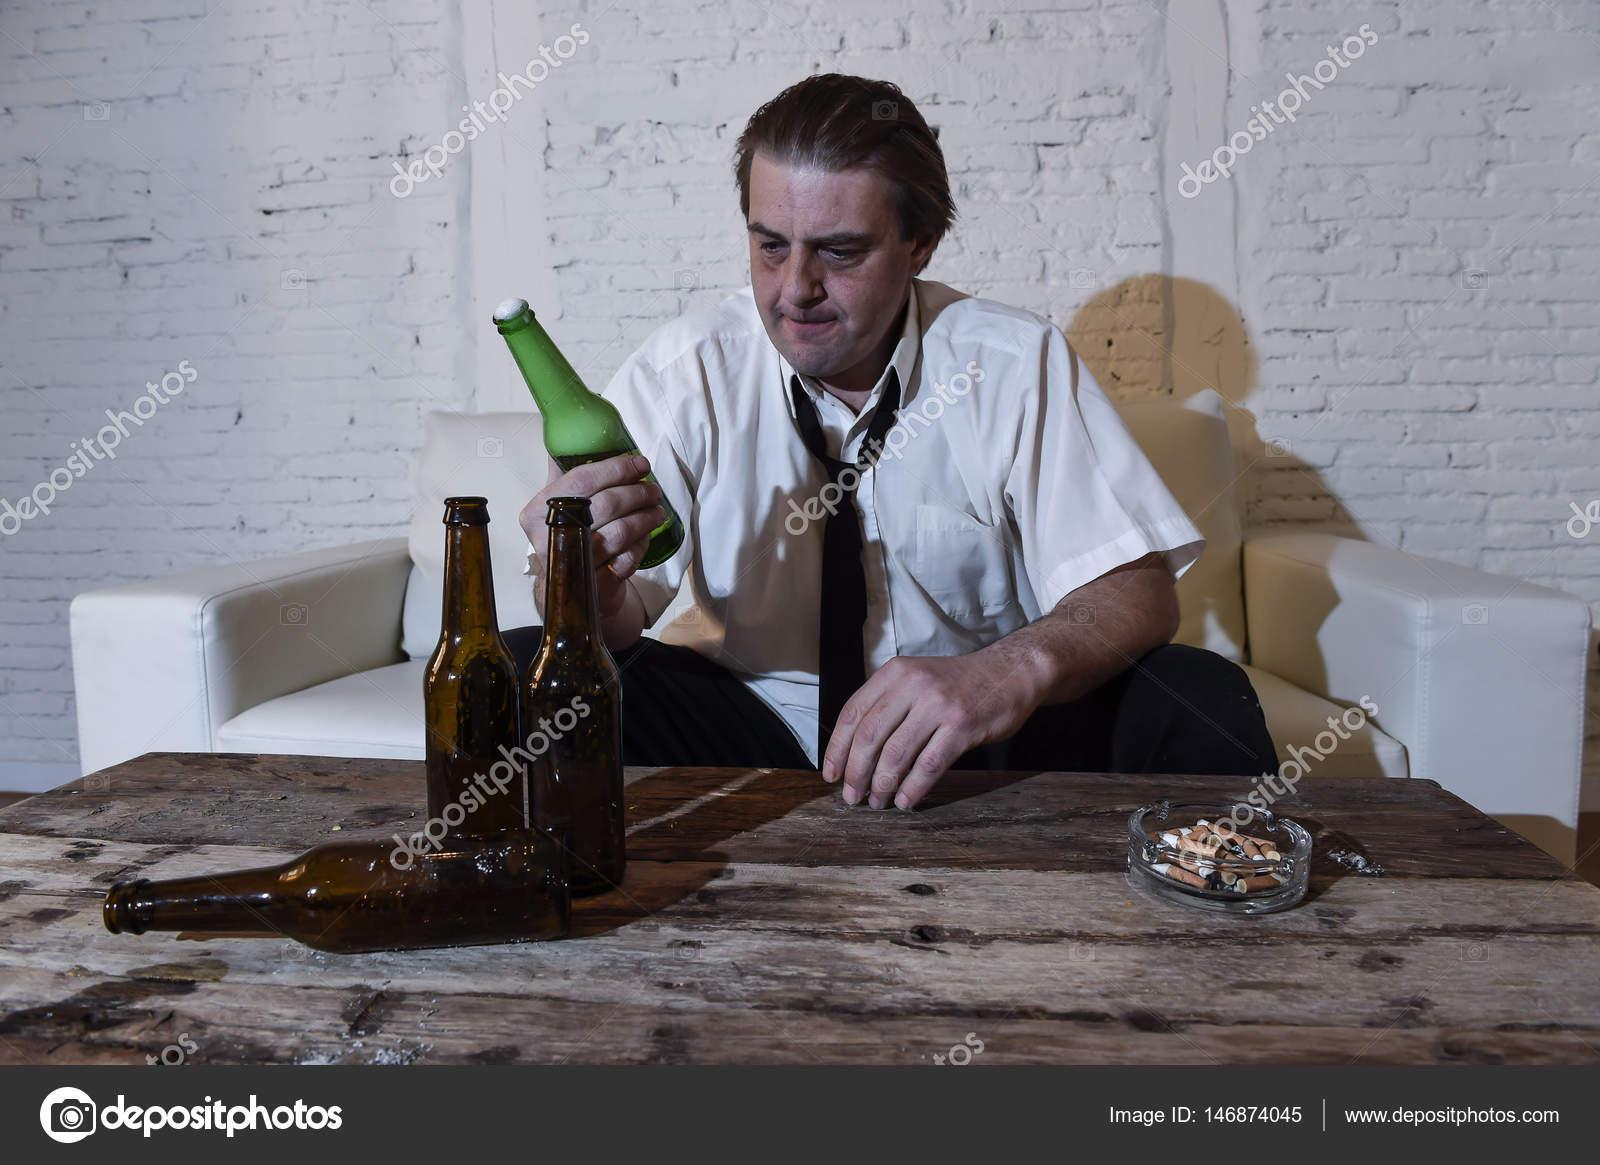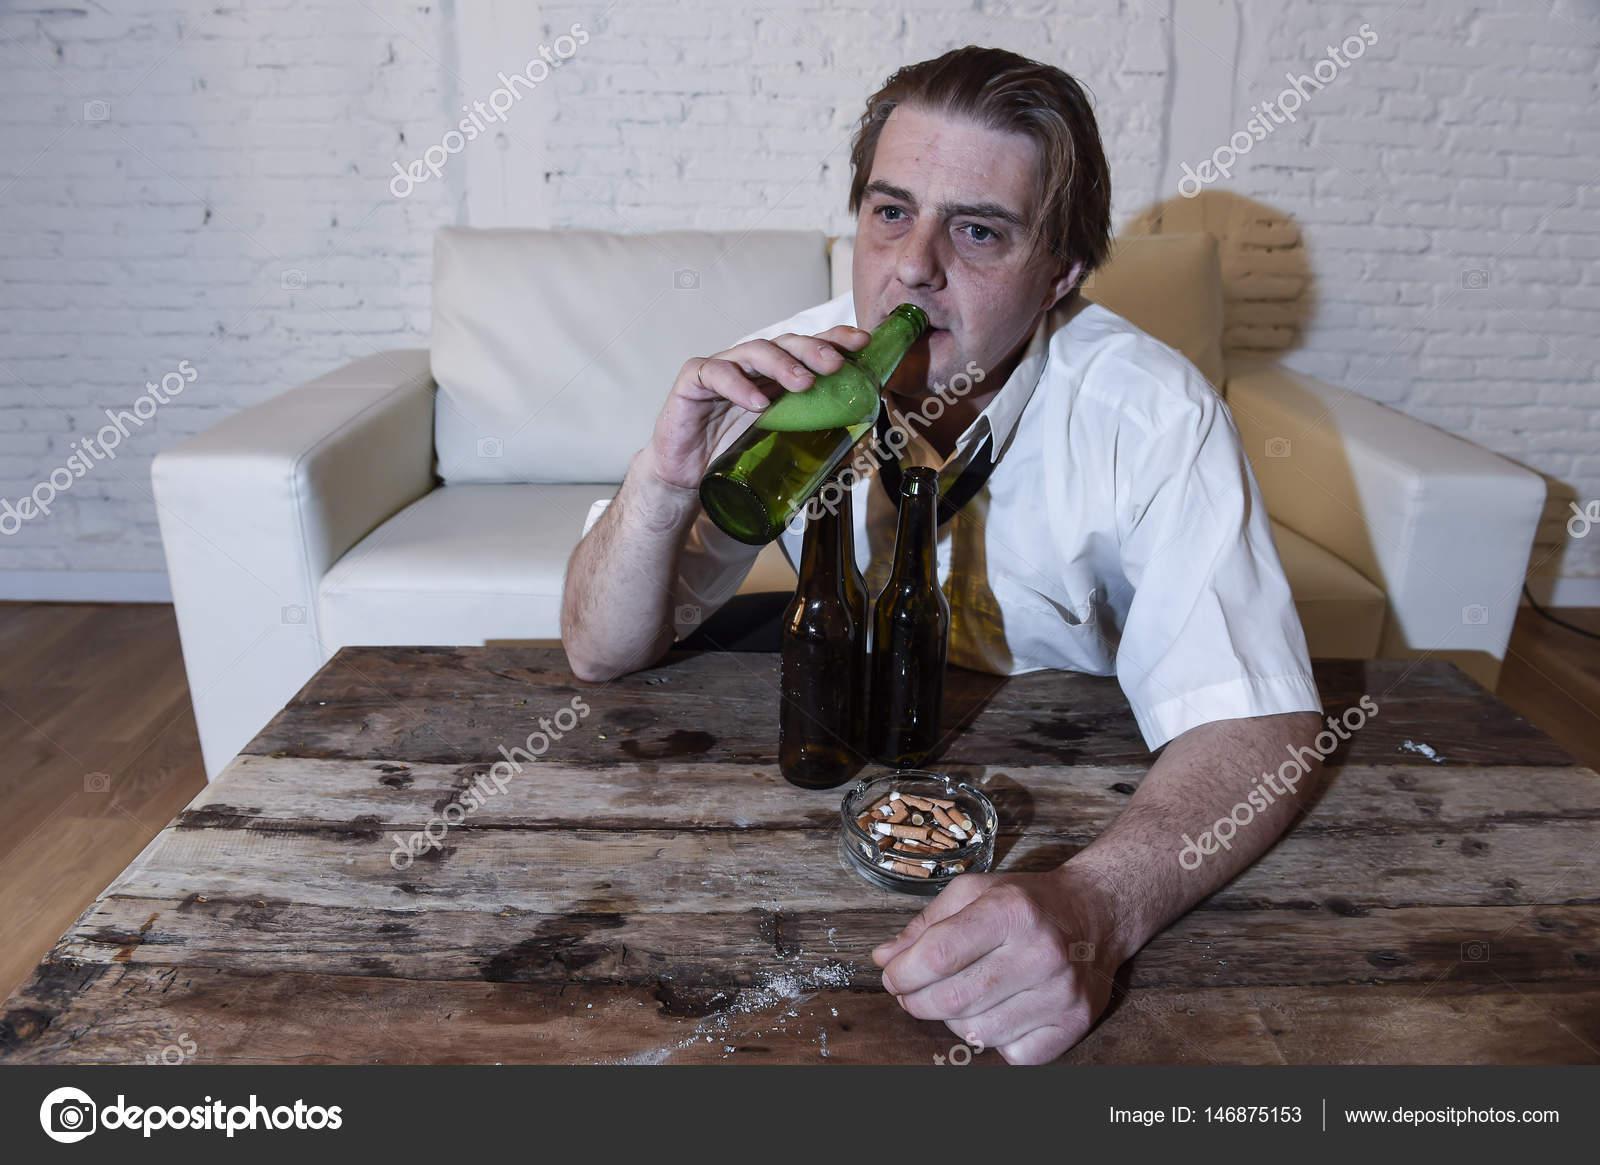The first image is the image on the left, the second image is the image on the right. Examine the images to the left and right. Is the description "A man is holding a bottle to his mouth." accurate? Answer yes or no. Yes. The first image is the image on the left, the second image is the image on the right. Examine the images to the left and right. Is the description "The man is drinking his beer in the left image." accurate? Answer yes or no. No. 